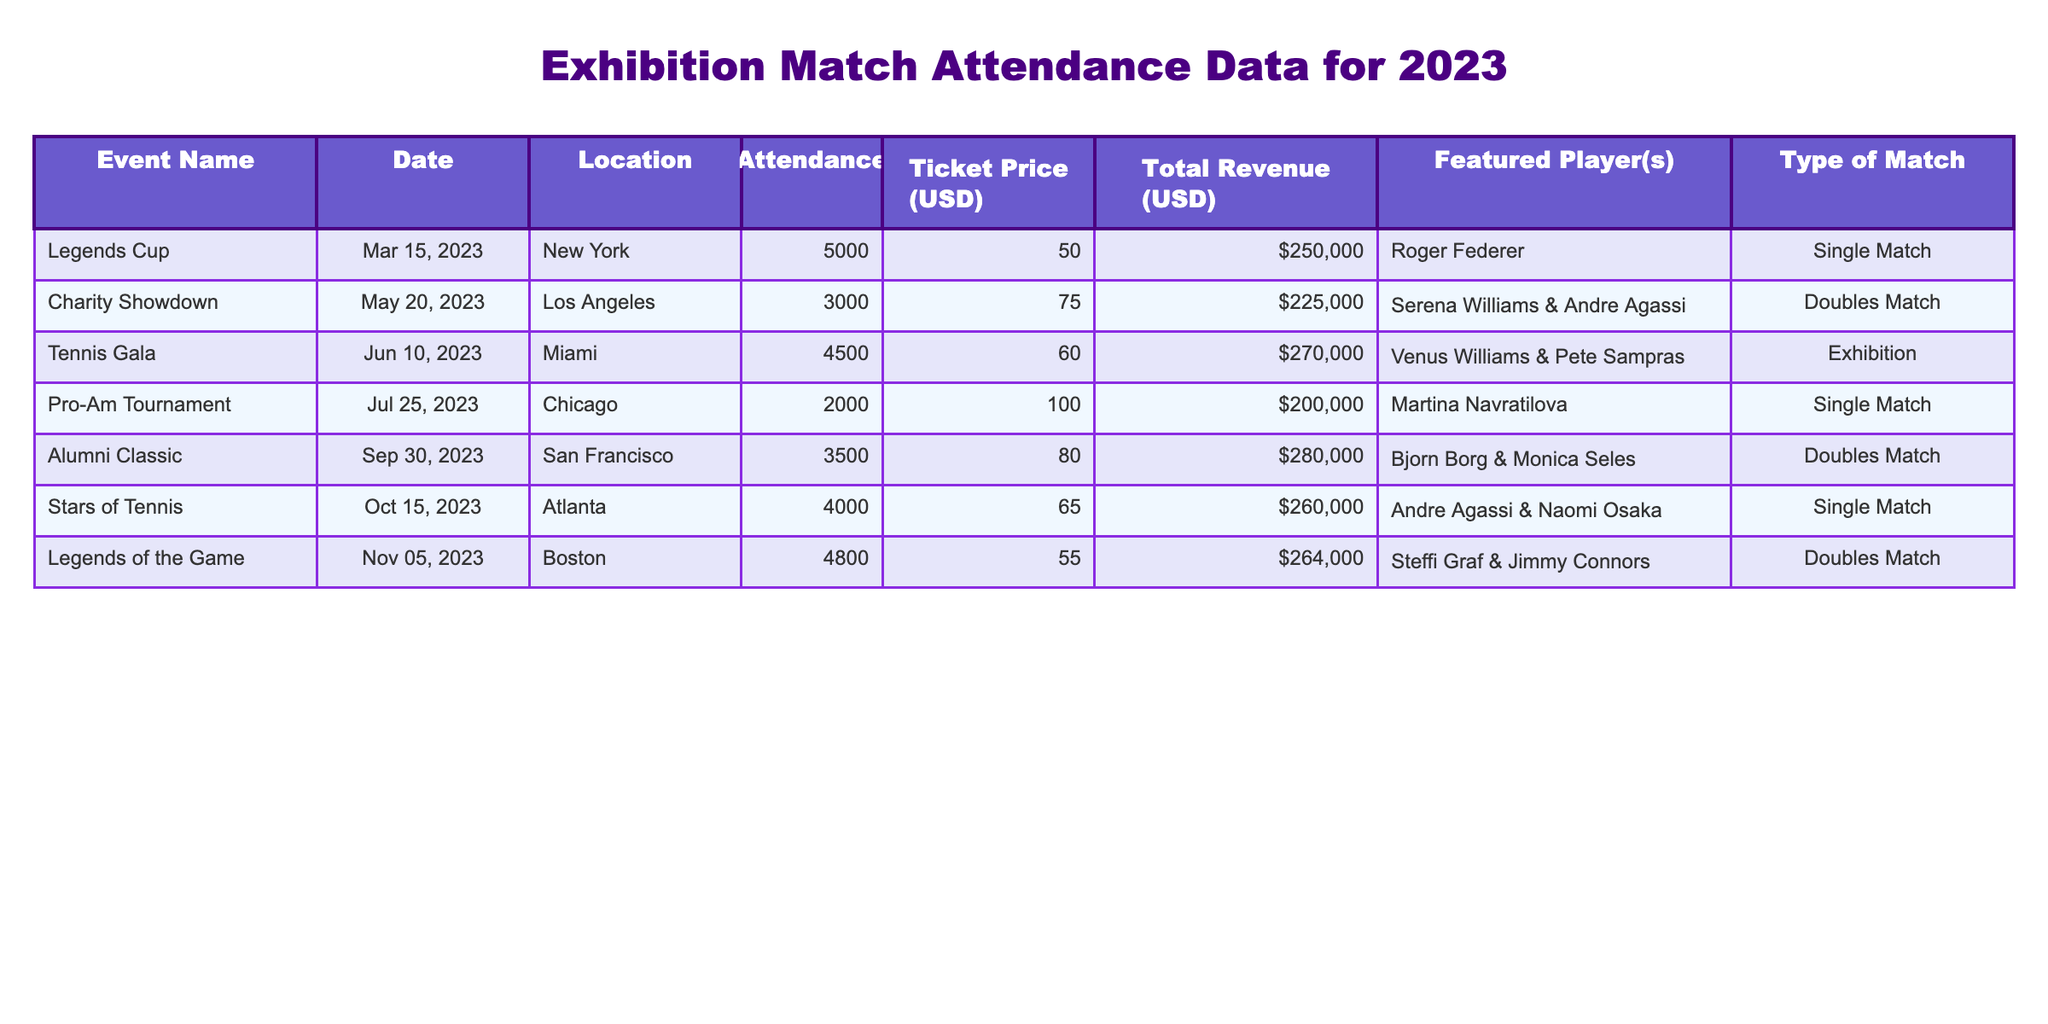What was the attendance for the Tennis Gala? The table lists the Tennis Gala under the 'Event Name' column with an attendance figure in the 'Attendance' column. For the Tennis Gala, the attendance is 4500.
Answer: 4500 Which event generated the highest total revenue? By examining the 'Total Revenue (USD)' column, the highest total revenue can be identified. The Legends Cup generated a total revenue of 250000, while the Alumni Classic had 280000. Therefore, the Alumni Classic generated the highest total revenue.
Answer: Alumni Classic Was there a single match event with more than 4000 attendees? The table can be checked for single matches and their respective attendance numbers. The Legends Cup (5000) and Stars of Tennis (4000) were both single matches, indicating that at least one single match had over 4000 attendees, namely the Legends Cup.
Answer: Yes What is the average ticket price for the events? To calculate the average ticket price, the 'Ticket Price (USD)' values need to be added together and divided by the number of events. The ticket prices are 50, 75, 60, 100, 80, 65, and 55, which sum to 495. Dividing by 7 (the total number of events) gives an average ticket price of approximately 70.71.
Answer: 70.71 Which featured player appeared in the highest attendance event? The event with the highest attendance was the Legends Cup (5000 attendees), and the featured player listed for this event is Roger Federer.
Answer: Roger Federer How much total revenue was earned from matches played in Boston? To find the total revenue from matches in Boston, we look at the location column. The 'Legends of the Game' event is the only match in Boston, with a total revenue of 264000. Thus, the total revenue from matches in Boston is 264000.
Answer: 264000 How many events had a ticket price less than 70 USD? By reviewing the 'Ticket Price (USD)' column for values under 70, the events with prices are 50, 60, and 55, indicating three events had ticket prices less than 70 USD (Legends Cup, Tennis Gala, and Legends of the Game).
Answer: 3 Which two players were featured in the Charity Showdown? The 'Featured Player(s)' column is examined for the Charity Showdown event. It indicates that Serena Williams and Andre Agassi were the featured players for this event.
Answer: Serena Williams & Andre Agassi 